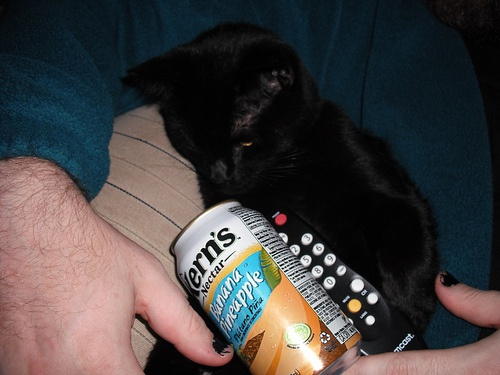Describe the objects in this image and their specific colors. I can see people in black, lightpink, gray, and salmon tones, cat in black, gray, and maroon tones, couch in black, gray, and darkgray tones, and remote in black, lightgray, darkgray, and gray tones in this image. 